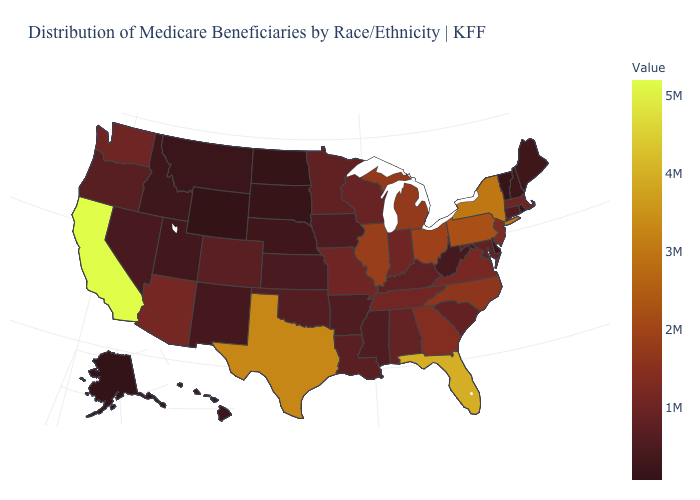Among the states that border North Carolina , does South Carolina have the lowest value?
Quick response, please. Yes. Among the states that border Minnesota , which have the lowest value?
Write a very short answer. North Dakota. Among the states that border Montana , which have the highest value?
Short answer required. Idaho. Does North Carolina have the highest value in the South?
Write a very short answer. No. Is the legend a continuous bar?
Keep it brief. Yes. Which states have the highest value in the USA?
Short answer required. California. 